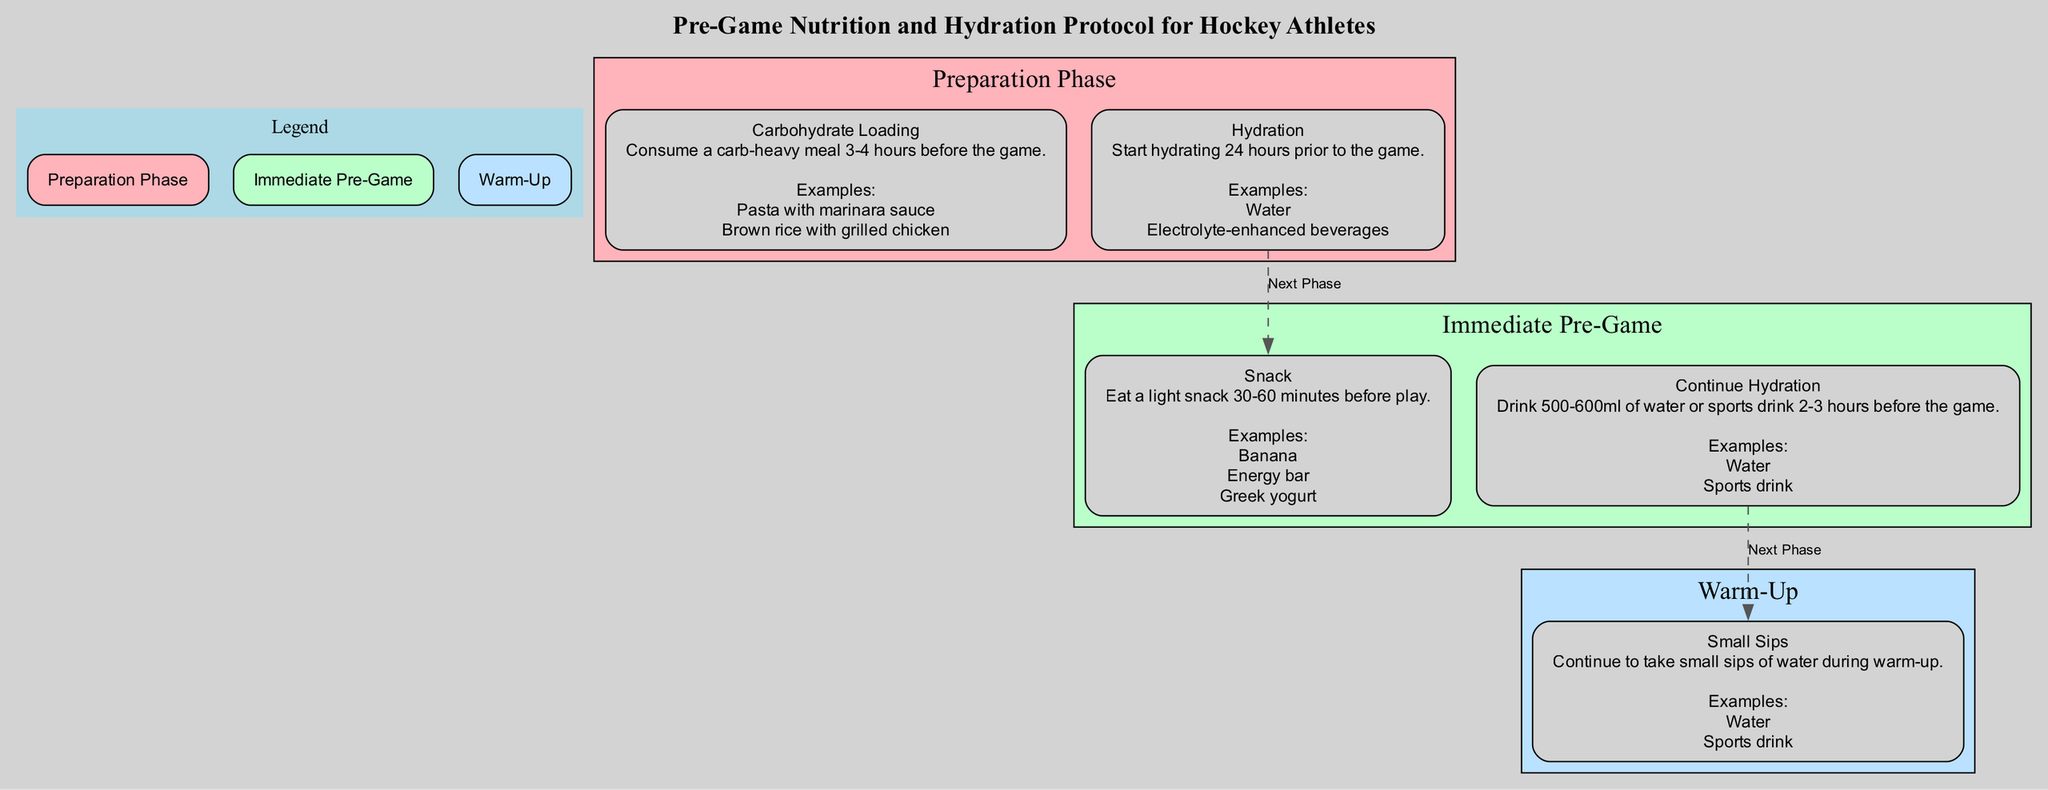How many phases are in the Clinical Pathway? There are three distinct phases: Preparation Phase, Immediate Pre-Game, and Warm-Up. Each phase is represented separately and labeled in the diagram.
Answer: 3 What is the first component in the Preparation Phase? The first component listed under the Preparation Phase is Carbohydrate Loading, as seen in the diagram, where it is the first item mentioned.
Answer: Carbohydrate Loading What beverage should be consumed during the Warm-Up phase? During the Warm-Up phase, athletes should continue to take small sips of either water or a sports drink, as indicated in the provided information in that phase.
Answer: Water or sports drink What type of meal is recommended 3-4 hours before the game? A carb-heavy meal such as pasta with marinara sauce or brown rice with grilled chicken is recommended, as stated under the Carbohydrate Loading component.
Answer: Carb-heavy meal How much water should athletes drink 2-3 hours before the game? Athletes are advised to drink 500-600ml of water or a sports drink 2-3 hours before the game, which is explicitly detailed in the Immediate Pre-Game phase.
Answer: 500-600ml What is the last phase in the Clinical Pathway? The last phase in the Clinical Pathway, as shown at the bottom of the diagram, is Warm-Up, concluding the sequence of preparation for the game.
Answer: Warm-Up Which snack option is mentioned for the Immediate Pre-Game? The diagram lists several snack options for the Immediate Pre-Game phase, specifically stating a banana, energy bar, or Greek yogurt as acceptable choices.
Answer: Banana, energy bar, or Greek yogurt What is the primary focus of the Preparation Phase? The primary focus of the Preparation Phase, indicated by the components listed, is on carbohydrate loading and hydration prior to the game, confirming athletes should prepare effectively.
Answer: Carbohydrate loading and hydration 